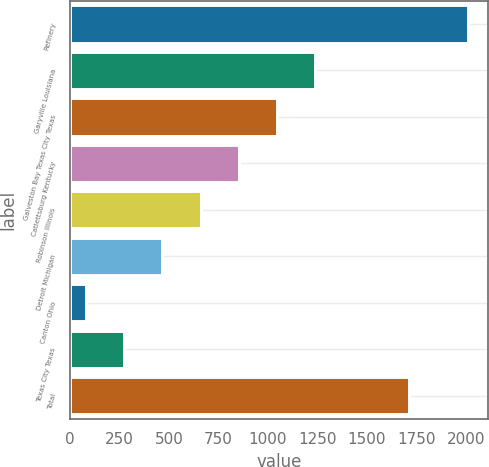Convert chart. <chart><loc_0><loc_0><loc_500><loc_500><bar_chart><fcel>Refinery<fcel>Garyville Louisiana<fcel>Galveston Bay Texas City Texas<fcel>Catlettsburg Kentucky<fcel>Robinson Illinois<fcel>Detroit Michigan<fcel>Canton Ohio<fcel>Texas City Texas<fcel>Total<nl><fcel>2013<fcel>1239.8<fcel>1046.5<fcel>853.2<fcel>659.9<fcel>466.6<fcel>80<fcel>273.3<fcel>1714<nl></chart> 